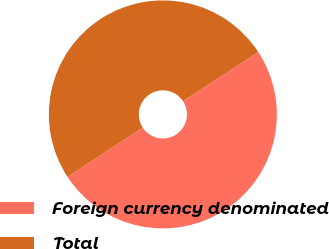<chart> <loc_0><loc_0><loc_500><loc_500><pie_chart><fcel>Foreign currency denominated<fcel>Total<nl><fcel>50.0%<fcel>50.0%<nl></chart> 